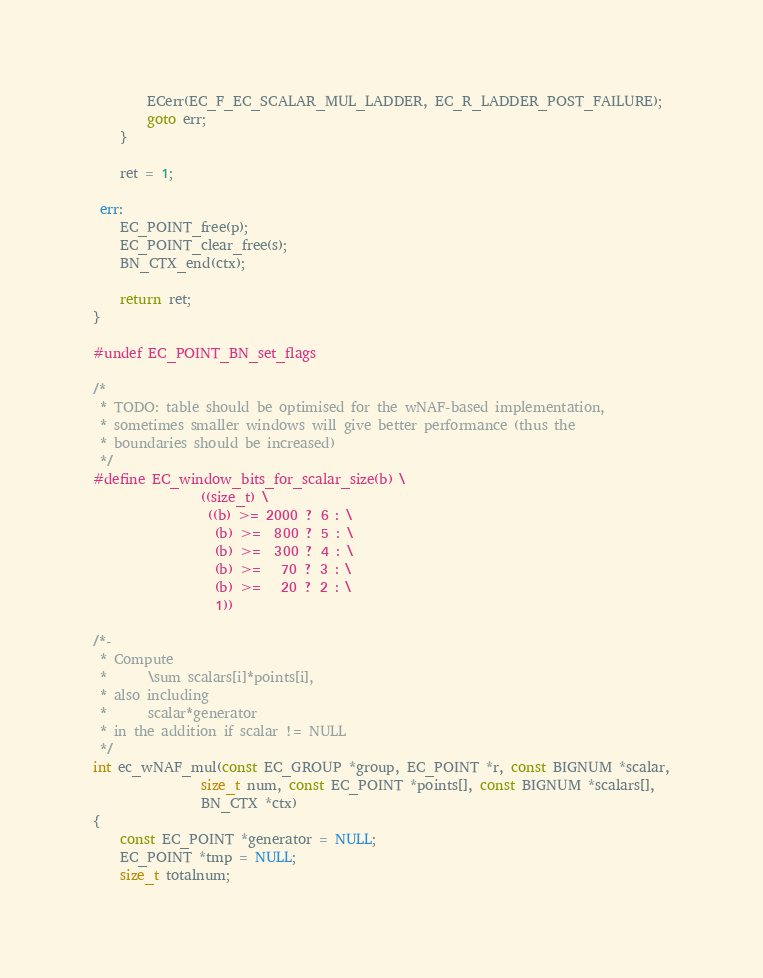<code> <loc_0><loc_0><loc_500><loc_500><_C_>        ECerr(EC_F_EC_SCALAR_MUL_LADDER, EC_R_LADDER_POST_FAILURE);
        goto err;
    }

    ret = 1;

 err:
    EC_POINT_free(p);
    EC_POINT_clear_free(s);
    BN_CTX_end(ctx);

    return ret;
}

#undef EC_POINT_BN_set_flags

/*
 * TODO: table should be optimised for the wNAF-based implementation,
 * sometimes smaller windows will give better performance (thus the
 * boundaries should be increased)
 */
#define EC_window_bits_for_scalar_size(b) \
                ((size_t) \
                 ((b) >= 2000 ? 6 : \
                  (b) >=  800 ? 5 : \
                  (b) >=  300 ? 4 : \
                  (b) >=   70 ? 3 : \
                  (b) >=   20 ? 2 : \
                  1))

/*-
 * Compute
 *      \sum scalars[i]*points[i],
 * also including
 *      scalar*generator
 * in the addition if scalar != NULL
 */
int ec_wNAF_mul(const EC_GROUP *group, EC_POINT *r, const BIGNUM *scalar,
                size_t num, const EC_POINT *points[], const BIGNUM *scalars[],
                BN_CTX *ctx)
{
    const EC_POINT *generator = NULL;
    EC_POINT *tmp = NULL;
    size_t totalnum;</code> 